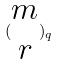Convert formula to latex. <formula><loc_0><loc_0><loc_500><loc_500>( \begin{matrix} m \\ r \end{matrix} ) _ { q }</formula> 